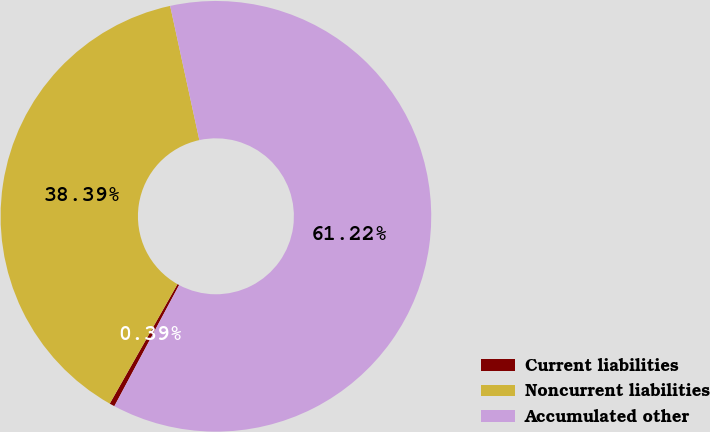Convert chart to OTSL. <chart><loc_0><loc_0><loc_500><loc_500><pie_chart><fcel>Current liabilities<fcel>Noncurrent liabilities<fcel>Accumulated other<nl><fcel>0.39%<fcel>38.39%<fcel>61.23%<nl></chart> 